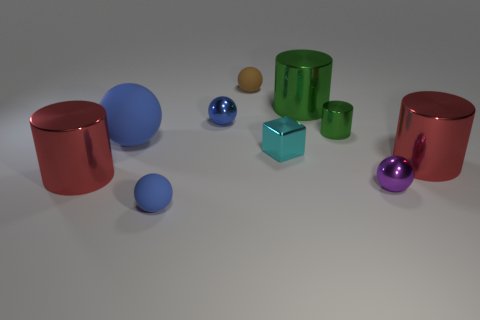There is a big red object that is left of the big red shiny cylinder to the right of the purple metallic ball; what number of green cylinders are to the left of it?
Ensure brevity in your answer.  0. There is a block in front of the blue metallic object; what is its size?
Offer a terse response. Small. How many shiny cubes are the same size as the purple metallic sphere?
Provide a short and direct response. 1. There is a brown ball; is it the same size as the red cylinder on the right side of the brown matte thing?
Make the answer very short. No. How many objects are cyan shiny objects or small blue metallic things?
Provide a succinct answer. 2. How many shiny things are the same color as the large ball?
Offer a very short reply. 1. What is the shape of the green metallic object that is the same size as the cyan shiny thing?
Make the answer very short. Cylinder. Are there any small brown objects of the same shape as the tiny purple object?
Ensure brevity in your answer.  Yes. How many other things are made of the same material as the cyan thing?
Offer a very short reply. 6. Are the big cylinder that is on the left side of the small blue rubber sphere and the cyan cube made of the same material?
Give a very brief answer. Yes. 